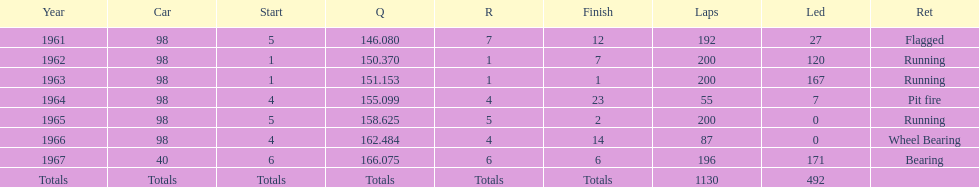What car achieved the highest qual? 40. 